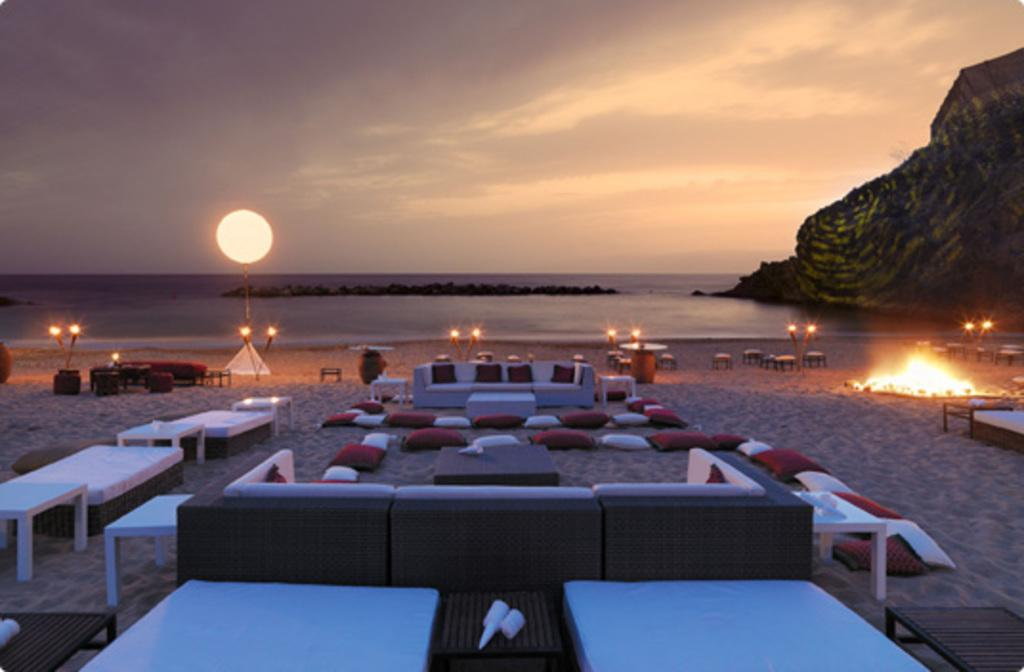What type of furniture can be seen in the image? There are tables and sofas in the image. What are the tables and sofas placed on? The tables, sofas, and cushions are placed on the seashore. What type of seating accessories are present in the image? There are cushions in the image. What can be seen in the background of the image? There is a sea, hills, and the sky visible in the background of the image. What might provide illumination in the image? There are lights in the image. How many dimes are scattered on the seashore in the image? There are no dimes present in the image; it features tables, sofas, cushions, lights, and the seashore. What type of wind can be seen in the image? There is no wind visible in the image; it is a still scene with tables, sofas, cushions, lights, and the seashore. 